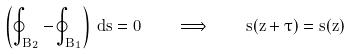<formula> <loc_0><loc_0><loc_500><loc_500>\left ( \oint _ { \hat { B } _ { 2 } } - \oint _ { \hat { B } _ { 1 } } \right ) \, d s = 0 \quad \implies \quad s ( z + \tau ) = s ( z )</formula> 